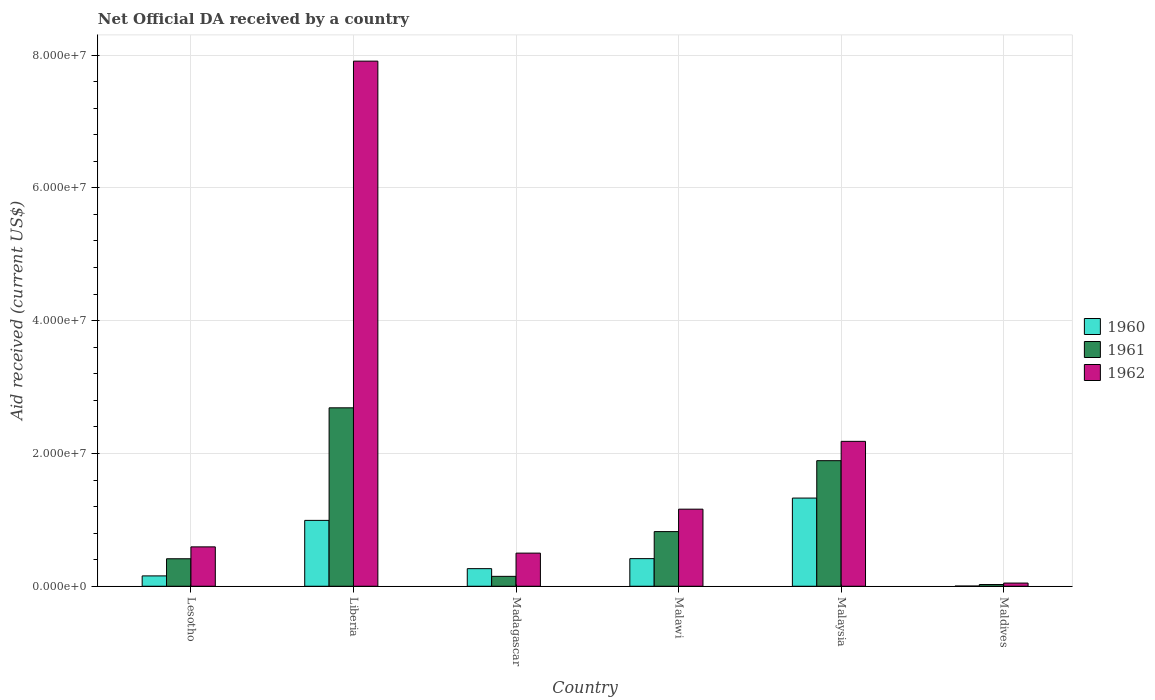Are the number of bars on each tick of the X-axis equal?
Make the answer very short. Yes. How many bars are there on the 1st tick from the left?
Provide a short and direct response. 3. What is the label of the 6th group of bars from the left?
Provide a short and direct response. Maldives. In how many cases, is the number of bars for a given country not equal to the number of legend labels?
Ensure brevity in your answer.  0. What is the net official development assistance aid received in 1960 in Liberia?
Offer a very short reply. 9.92e+06. Across all countries, what is the maximum net official development assistance aid received in 1960?
Keep it short and to the point. 1.33e+07. Across all countries, what is the minimum net official development assistance aid received in 1961?
Your answer should be very brief. 2.60e+05. In which country was the net official development assistance aid received in 1962 maximum?
Ensure brevity in your answer.  Liberia. In which country was the net official development assistance aid received in 1960 minimum?
Your response must be concise. Maldives. What is the total net official development assistance aid received in 1961 in the graph?
Your response must be concise. 5.99e+07. What is the difference between the net official development assistance aid received in 1960 in Liberia and that in Madagascar?
Ensure brevity in your answer.  7.27e+06. What is the difference between the net official development assistance aid received in 1961 in Malaysia and the net official development assistance aid received in 1962 in Madagascar?
Make the answer very short. 1.39e+07. What is the average net official development assistance aid received in 1960 per country?
Make the answer very short. 5.27e+06. What is the difference between the net official development assistance aid received of/in 1962 and net official development assistance aid received of/in 1961 in Liberia?
Give a very brief answer. 5.22e+07. What is the ratio of the net official development assistance aid received in 1961 in Madagascar to that in Malawi?
Your answer should be compact. 0.18. What is the difference between the highest and the second highest net official development assistance aid received in 1962?
Give a very brief answer. 5.73e+07. What is the difference between the highest and the lowest net official development assistance aid received in 1962?
Your response must be concise. 7.86e+07. Is the sum of the net official development assistance aid received in 1962 in Liberia and Madagascar greater than the maximum net official development assistance aid received in 1961 across all countries?
Make the answer very short. Yes. What does the 2nd bar from the right in Malawi represents?
Make the answer very short. 1961. Is it the case that in every country, the sum of the net official development assistance aid received in 1960 and net official development assistance aid received in 1962 is greater than the net official development assistance aid received in 1961?
Make the answer very short. Yes. How many bars are there?
Your answer should be very brief. 18. Does the graph contain any zero values?
Your answer should be very brief. No. Does the graph contain grids?
Give a very brief answer. Yes. How many legend labels are there?
Give a very brief answer. 3. What is the title of the graph?
Your answer should be compact. Net Official DA received by a country. Does "1977" appear as one of the legend labels in the graph?
Your answer should be compact. No. What is the label or title of the Y-axis?
Give a very brief answer. Aid received (current US$). What is the Aid received (current US$) in 1960 in Lesotho?
Your answer should be compact. 1.56e+06. What is the Aid received (current US$) of 1961 in Lesotho?
Make the answer very short. 4.14e+06. What is the Aid received (current US$) of 1962 in Lesotho?
Provide a short and direct response. 5.93e+06. What is the Aid received (current US$) of 1960 in Liberia?
Ensure brevity in your answer.  9.92e+06. What is the Aid received (current US$) of 1961 in Liberia?
Give a very brief answer. 2.69e+07. What is the Aid received (current US$) in 1962 in Liberia?
Make the answer very short. 7.91e+07. What is the Aid received (current US$) of 1960 in Madagascar?
Ensure brevity in your answer.  2.65e+06. What is the Aid received (current US$) in 1961 in Madagascar?
Ensure brevity in your answer.  1.49e+06. What is the Aid received (current US$) in 1962 in Madagascar?
Offer a terse response. 4.99e+06. What is the Aid received (current US$) of 1960 in Malawi?
Your response must be concise. 4.16e+06. What is the Aid received (current US$) of 1961 in Malawi?
Provide a succinct answer. 8.23e+06. What is the Aid received (current US$) of 1962 in Malawi?
Provide a succinct answer. 1.16e+07. What is the Aid received (current US$) of 1960 in Malaysia?
Your answer should be very brief. 1.33e+07. What is the Aid received (current US$) of 1961 in Malaysia?
Your answer should be very brief. 1.89e+07. What is the Aid received (current US$) of 1962 in Malaysia?
Your response must be concise. 2.18e+07. What is the Aid received (current US$) of 1960 in Maldives?
Make the answer very short. 3.00e+04. Across all countries, what is the maximum Aid received (current US$) in 1960?
Offer a terse response. 1.33e+07. Across all countries, what is the maximum Aid received (current US$) in 1961?
Your answer should be very brief. 2.69e+07. Across all countries, what is the maximum Aid received (current US$) in 1962?
Keep it short and to the point. 7.91e+07. Across all countries, what is the minimum Aid received (current US$) of 1960?
Provide a short and direct response. 3.00e+04. What is the total Aid received (current US$) in 1960 in the graph?
Give a very brief answer. 3.16e+07. What is the total Aid received (current US$) in 1961 in the graph?
Your response must be concise. 5.99e+07. What is the total Aid received (current US$) of 1962 in the graph?
Ensure brevity in your answer.  1.24e+08. What is the difference between the Aid received (current US$) of 1960 in Lesotho and that in Liberia?
Provide a short and direct response. -8.36e+06. What is the difference between the Aid received (current US$) in 1961 in Lesotho and that in Liberia?
Your response must be concise. -2.27e+07. What is the difference between the Aid received (current US$) in 1962 in Lesotho and that in Liberia?
Your answer should be very brief. -7.32e+07. What is the difference between the Aid received (current US$) of 1960 in Lesotho and that in Madagascar?
Offer a very short reply. -1.09e+06. What is the difference between the Aid received (current US$) in 1961 in Lesotho and that in Madagascar?
Offer a very short reply. 2.65e+06. What is the difference between the Aid received (current US$) in 1962 in Lesotho and that in Madagascar?
Keep it short and to the point. 9.40e+05. What is the difference between the Aid received (current US$) in 1960 in Lesotho and that in Malawi?
Your answer should be very brief. -2.60e+06. What is the difference between the Aid received (current US$) of 1961 in Lesotho and that in Malawi?
Your response must be concise. -4.09e+06. What is the difference between the Aid received (current US$) in 1962 in Lesotho and that in Malawi?
Give a very brief answer. -5.68e+06. What is the difference between the Aid received (current US$) in 1960 in Lesotho and that in Malaysia?
Your answer should be compact. -1.17e+07. What is the difference between the Aid received (current US$) in 1961 in Lesotho and that in Malaysia?
Your response must be concise. -1.48e+07. What is the difference between the Aid received (current US$) of 1962 in Lesotho and that in Malaysia?
Your response must be concise. -1.59e+07. What is the difference between the Aid received (current US$) of 1960 in Lesotho and that in Maldives?
Offer a very short reply. 1.53e+06. What is the difference between the Aid received (current US$) in 1961 in Lesotho and that in Maldives?
Make the answer very short. 3.88e+06. What is the difference between the Aid received (current US$) in 1962 in Lesotho and that in Maldives?
Your response must be concise. 5.45e+06. What is the difference between the Aid received (current US$) in 1960 in Liberia and that in Madagascar?
Provide a succinct answer. 7.27e+06. What is the difference between the Aid received (current US$) in 1961 in Liberia and that in Madagascar?
Make the answer very short. 2.54e+07. What is the difference between the Aid received (current US$) of 1962 in Liberia and that in Madagascar?
Provide a succinct answer. 7.41e+07. What is the difference between the Aid received (current US$) of 1960 in Liberia and that in Malawi?
Keep it short and to the point. 5.76e+06. What is the difference between the Aid received (current US$) of 1961 in Liberia and that in Malawi?
Your answer should be very brief. 1.86e+07. What is the difference between the Aid received (current US$) of 1962 in Liberia and that in Malawi?
Make the answer very short. 6.75e+07. What is the difference between the Aid received (current US$) of 1960 in Liberia and that in Malaysia?
Your response must be concise. -3.36e+06. What is the difference between the Aid received (current US$) of 1961 in Liberia and that in Malaysia?
Provide a short and direct response. 7.96e+06. What is the difference between the Aid received (current US$) of 1962 in Liberia and that in Malaysia?
Give a very brief answer. 5.73e+07. What is the difference between the Aid received (current US$) in 1960 in Liberia and that in Maldives?
Keep it short and to the point. 9.89e+06. What is the difference between the Aid received (current US$) in 1961 in Liberia and that in Maldives?
Your response must be concise. 2.66e+07. What is the difference between the Aid received (current US$) of 1962 in Liberia and that in Maldives?
Your response must be concise. 7.86e+07. What is the difference between the Aid received (current US$) of 1960 in Madagascar and that in Malawi?
Make the answer very short. -1.51e+06. What is the difference between the Aid received (current US$) of 1961 in Madagascar and that in Malawi?
Your answer should be very brief. -6.74e+06. What is the difference between the Aid received (current US$) in 1962 in Madagascar and that in Malawi?
Provide a succinct answer. -6.62e+06. What is the difference between the Aid received (current US$) of 1960 in Madagascar and that in Malaysia?
Your response must be concise. -1.06e+07. What is the difference between the Aid received (current US$) in 1961 in Madagascar and that in Malaysia?
Your answer should be very brief. -1.74e+07. What is the difference between the Aid received (current US$) in 1962 in Madagascar and that in Malaysia?
Your response must be concise. -1.68e+07. What is the difference between the Aid received (current US$) in 1960 in Madagascar and that in Maldives?
Provide a succinct answer. 2.62e+06. What is the difference between the Aid received (current US$) of 1961 in Madagascar and that in Maldives?
Provide a succinct answer. 1.23e+06. What is the difference between the Aid received (current US$) of 1962 in Madagascar and that in Maldives?
Offer a terse response. 4.51e+06. What is the difference between the Aid received (current US$) in 1960 in Malawi and that in Malaysia?
Keep it short and to the point. -9.12e+06. What is the difference between the Aid received (current US$) of 1961 in Malawi and that in Malaysia?
Offer a terse response. -1.07e+07. What is the difference between the Aid received (current US$) of 1962 in Malawi and that in Malaysia?
Your response must be concise. -1.02e+07. What is the difference between the Aid received (current US$) in 1960 in Malawi and that in Maldives?
Your response must be concise. 4.13e+06. What is the difference between the Aid received (current US$) of 1961 in Malawi and that in Maldives?
Offer a very short reply. 7.97e+06. What is the difference between the Aid received (current US$) of 1962 in Malawi and that in Maldives?
Keep it short and to the point. 1.11e+07. What is the difference between the Aid received (current US$) in 1960 in Malaysia and that in Maldives?
Offer a very short reply. 1.32e+07. What is the difference between the Aid received (current US$) in 1961 in Malaysia and that in Maldives?
Provide a succinct answer. 1.86e+07. What is the difference between the Aid received (current US$) of 1962 in Malaysia and that in Maldives?
Your response must be concise. 2.13e+07. What is the difference between the Aid received (current US$) in 1960 in Lesotho and the Aid received (current US$) in 1961 in Liberia?
Your response must be concise. -2.53e+07. What is the difference between the Aid received (current US$) of 1960 in Lesotho and the Aid received (current US$) of 1962 in Liberia?
Offer a terse response. -7.75e+07. What is the difference between the Aid received (current US$) of 1961 in Lesotho and the Aid received (current US$) of 1962 in Liberia?
Ensure brevity in your answer.  -7.49e+07. What is the difference between the Aid received (current US$) of 1960 in Lesotho and the Aid received (current US$) of 1961 in Madagascar?
Your answer should be very brief. 7.00e+04. What is the difference between the Aid received (current US$) in 1960 in Lesotho and the Aid received (current US$) in 1962 in Madagascar?
Offer a very short reply. -3.43e+06. What is the difference between the Aid received (current US$) in 1961 in Lesotho and the Aid received (current US$) in 1962 in Madagascar?
Give a very brief answer. -8.50e+05. What is the difference between the Aid received (current US$) in 1960 in Lesotho and the Aid received (current US$) in 1961 in Malawi?
Provide a succinct answer. -6.67e+06. What is the difference between the Aid received (current US$) of 1960 in Lesotho and the Aid received (current US$) of 1962 in Malawi?
Your answer should be compact. -1.00e+07. What is the difference between the Aid received (current US$) of 1961 in Lesotho and the Aid received (current US$) of 1962 in Malawi?
Offer a terse response. -7.47e+06. What is the difference between the Aid received (current US$) in 1960 in Lesotho and the Aid received (current US$) in 1961 in Malaysia?
Provide a short and direct response. -1.74e+07. What is the difference between the Aid received (current US$) in 1960 in Lesotho and the Aid received (current US$) in 1962 in Malaysia?
Provide a succinct answer. -2.03e+07. What is the difference between the Aid received (current US$) of 1961 in Lesotho and the Aid received (current US$) of 1962 in Malaysia?
Provide a succinct answer. -1.77e+07. What is the difference between the Aid received (current US$) in 1960 in Lesotho and the Aid received (current US$) in 1961 in Maldives?
Offer a very short reply. 1.30e+06. What is the difference between the Aid received (current US$) in 1960 in Lesotho and the Aid received (current US$) in 1962 in Maldives?
Keep it short and to the point. 1.08e+06. What is the difference between the Aid received (current US$) in 1961 in Lesotho and the Aid received (current US$) in 1962 in Maldives?
Give a very brief answer. 3.66e+06. What is the difference between the Aid received (current US$) in 1960 in Liberia and the Aid received (current US$) in 1961 in Madagascar?
Your response must be concise. 8.43e+06. What is the difference between the Aid received (current US$) of 1960 in Liberia and the Aid received (current US$) of 1962 in Madagascar?
Offer a very short reply. 4.93e+06. What is the difference between the Aid received (current US$) in 1961 in Liberia and the Aid received (current US$) in 1962 in Madagascar?
Offer a very short reply. 2.19e+07. What is the difference between the Aid received (current US$) of 1960 in Liberia and the Aid received (current US$) of 1961 in Malawi?
Offer a terse response. 1.69e+06. What is the difference between the Aid received (current US$) of 1960 in Liberia and the Aid received (current US$) of 1962 in Malawi?
Make the answer very short. -1.69e+06. What is the difference between the Aid received (current US$) in 1961 in Liberia and the Aid received (current US$) in 1962 in Malawi?
Keep it short and to the point. 1.53e+07. What is the difference between the Aid received (current US$) in 1960 in Liberia and the Aid received (current US$) in 1961 in Malaysia?
Make the answer very short. -8.99e+06. What is the difference between the Aid received (current US$) of 1960 in Liberia and the Aid received (current US$) of 1962 in Malaysia?
Offer a very short reply. -1.19e+07. What is the difference between the Aid received (current US$) of 1961 in Liberia and the Aid received (current US$) of 1962 in Malaysia?
Your answer should be very brief. 5.05e+06. What is the difference between the Aid received (current US$) of 1960 in Liberia and the Aid received (current US$) of 1961 in Maldives?
Give a very brief answer. 9.66e+06. What is the difference between the Aid received (current US$) in 1960 in Liberia and the Aid received (current US$) in 1962 in Maldives?
Ensure brevity in your answer.  9.44e+06. What is the difference between the Aid received (current US$) of 1961 in Liberia and the Aid received (current US$) of 1962 in Maldives?
Keep it short and to the point. 2.64e+07. What is the difference between the Aid received (current US$) in 1960 in Madagascar and the Aid received (current US$) in 1961 in Malawi?
Provide a short and direct response. -5.58e+06. What is the difference between the Aid received (current US$) of 1960 in Madagascar and the Aid received (current US$) of 1962 in Malawi?
Your answer should be very brief. -8.96e+06. What is the difference between the Aid received (current US$) of 1961 in Madagascar and the Aid received (current US$) of 1962 in Malawi?
Offer a terse response. -1.01e+07. What is the difference between the Aid received (current US$) of 1960 in Madagascar and the Aid received (current US$) of 1961 in Malaysia?
Keep it short and to the point. -1.63e+07. What is the difference between the Aid received (current US$) of 1960 in Madagascar and the Aid received (current US$) of 1962 in Malaysia?
Your answer should be very brief. -1.92e+07. What is the difference between the Aid received (current US$) of 1961 in Madagascar and the Aid received (current US$) of 1962 in Malaysia?
Your response must be concise. -2.03e+07. What is the difference between the Aid received (current US$) in 1960 in Madagascar and the Aid received (current US$) in 1961 in Maldives?
Keep it short and to the point. 2.39e+06. What is the difference between the Aid received (current US$) in 1960 in Madagascar and the Aid received (current US$) in 1962 in Maldives?
Provide a succinct answer. 2.17e+06. What is the difference between the Aid received (current US$) in 1961 in Madagascar and the Aid received (current US$) in 1962 in Maldives?
Offer a very short reply. 1.01e+06. What is the difference between the Aid received (current US$) of 1960 in Malawi and the Aid received (current US$) of 1961 in Malaysia?
Your response must be concise. -1.48e+07. What is the difference between the Aid received (current US$) in 1960 in Malawi and the Aid received (current US$) in 1962 in Malaysia?
Provide a short and direct response. -1.77e+07. What is the difference between the Aid received (current US$) in 1961 in Malawi and the Aid received (current US$) in 1962 in Malaysia?
Your answer should be very brief. -1.36e+07. What is the difference between the Aid received (current US$) in 1960 in Malawi and the Aid received (current US$) in 1961 in Maldives?
Provide a short and direct response. 3.90e+06. What is the difference between the Aid received (current US$) of 1960 in Malawi and the Aid received (current US$) of 1962 in Maldives?
Your answer should be compact. 3.68e+06. What is the difference between the Aid received (current US$) in 1961 in Malawi and the Aid received (current US$) in 1962 in Maldives?
Your answer should be very brief. 7.75e+06. What is the difference between the Aid received (current US$) in 1960 in Malaysia and the Aid received (current US$) in 1961 in Maldives?
Ensure brevity in your answer.  1.30e+07. What is the difference between the Aid received (current US$) of 1960 in Malaysia and the Aid received (current US$) of 1962 in Maldives?
Your answer should be very brief. 1.28e+07. What is the difference between the Aid received (current US$) in 1961 in Malaysia and the Aid received (current US$) in 1962 in Maldives?
Make the answer very short. 1.84e+07. What is the average Aid received (current US$) of 1960 per country?
Offer a terse response. 5.27e+06. What is the average Aid received (current US$) in 1961 per country?
Provide a succinct answer. 9.98e+06. What is the average Aid received (current US$) in 1962 per country?
Make the answer very short. 2.07e+07. What is the difference between the Aid received (current US$) of 1960 and Aid received (current US$) of 1961 in Lesotho?
Your answer should be very brief. -2.58e+06. What is the difference between the Aid received (current US$) in 1960 and Aid received (current US$) in 1962 in Lesotho?
Provide a short and direct response. -4.37e+06. What is the difference between the Aid received (current US$) of 1961 and Aid received (current US$) of 1962 in Lesotho?
Offer a very short reply. -1.79e+06. What is the difference between the Aid received (current US$) in 1960 and Aid received (current US$) in 1961 in Liberia?
Provide a succinct answer. -1.70e+07. What is the difference between the Aid received (current US$) of 1960 and Aid received (current US$) of 1962 in Liberia?
Make the answer very short. -6.92e+07. What is the difference between the Aid received (current US$) in 1961 and Aid received (current US$) in 1962 in Liberia?
Offer a very short reply. -5.22e+07. What is the difference between the Aid received (current US$) in 1960 and Aid received (current US$) in 1961 in Madagascar?
Ensure brevity in your answer.  1.16e+06. What is the difference between the Aid received (current US$) in 1960 and Aid received (current US$) in 1962 in Madagascar?
Your response must be concise. -2.34e+06. What is the difference between the Aid received (current US$) in 1961 and Aid received (current US$) in 1962 in Madagascar?
Offer a terse response. -3.50e+06. What is the difference between the Aid received (current US$) in 1960 and Aid received (current US$) in 1961 in Malawi?
Provide a short and direct response. -4.07e+06. What is the difference between the Aid received (current US$) of 1960 and Aid received (current US$) of 1962 in Malawi?
Your answer should be very brief. -7.45e+06. What is the difference between the Aid received (current US$) of 1961 and Aid received (current US$) of 1962 in Malawi?
Offer a terse response. -3.38e+06. What is the difference between the Aid received (current US$) in 1960 and Aid received (current US$) in 1961 in Malaysia?
Give a very brief answer. -5.63e+06. What is the difference between the Aid received (current US$) of 1960 and Aid received (current US$) of 1962 in Malaysia?
Offer a terse response. -8.54e+06. What is the difference between the Aid received (current US$) of 1961 and Aid received (current US$) of 1962 in Malaysia?
Give a very brief answer. -2.91e+06. What is the difference between the Aid received (current US$) in 1960 and Aid received (current US$) in 1962 in Maldives?
Offer a very short reply. -4.50e+05. What is the ratio of the Aid received (current US$) of 1960 in Lesotho to that in Liberia?
Your answer should be very brief. 0.16. What is the ratio of the Aid received (current US$) of 1961 in Lesotho to that in Liberia?
Keep it short and to the point. 0.15. What is the ratio of the Aid received (current US$) of 1962 in Lesotho to that in Liberia?
Make the answer very short. 0.07. What is the ratio of the Aid received (current US$) of 1960 in Lesotho to that in Madagascar?
Ensure brevity in your answer.  0.59. What is the ratio of the Aid received (current US$) of 1961 in Lesotho to that in Madagascar?
Your response must be concise. 2.78. What is the ratio of the Aid received (current US$) of 1962 in Lesotho to that in Madagascar?
Give a very brief answer. 1.19. What is the ratio of the Aid received (current US$) of 1960 in Lesotho to that in Malawi?
Ensure brevity in your answer.  0.38. What is the ratio of the Aid received (current US$) of 1961 in Lesotho to that in Malawi?
Your answer should be very brief. 0.5. What is the ratio of the Aid received (current US$) of 1962 in Lesotho to that in Malawi?
Your response must be concise. 0.51. What is the ratio of the Aid received (current US$) in 1960 in Lesotho to that in Malaysia?
Make the answer very short. 0.12. What is the ratio of the Aid received (current US$) of 1961 in Lesotho to that in Malaysia?
Your answer should be compact. 0.22. What is the ratio of the Aid received (current US$) in 1962 in Lesotho to that in Malaysia?
Your answer should be very brief. 0.27. What is the ratio of the Aid received (current US$) in 1961 in Lesotho to that in Maldives?
Provide a short and direct response. 15.92. What is the ratio of the Aid received (current US$) in 1962 in Lesotho to that in Maldives?
Your answer should be compact. 12.35. What is the ratio of the Aid received (current US$) of 1960 in Liberia to that in Madagascar?
Provide a short and direct response. 3.74. What is the ratio of the Aid received (current US$) of 1961 in Liberia to that in Madagascar?
Your answer should be compact. 18.03. What is the ratio of the Aid received (current US$) of 1962 in Liberia to that in Madagascar?
Offer a very short reply. 15.85. What is the ratio of the Aid received (current US$) in 1960 in Liberia to that in Malawi?
Give a very brief answer. 2.38. What is the ratio of the Aid received (current US$) of 1961 in Liberia to that in Malawi?
Offer a very short reply. 3.26. What is the ratio of the Aid received (current US$) of 1962 in Liberia to that in Malawi?
Make the answer very short. 6.81. What is the ratio of the Aid received (current US$) of 1960 in Liberia to that in Malaysia?
Give a very brief answer. 0.75. What is the ratio of the Aid received (current US$) of 1961 in Liberia to that in Malaysia?
Offer a very short reply. 1.42. What is the ratio of the Aid received (current US$) in 1962 in Liberia to that in Malaysia?
Your answer should be compact. 3.62. What is the ratio of the Aid received (current US$) in 1960 in Liberia to that in Maldives?
Your response must be concise. 330.67. What is the ratio of the Aid received (current US$) in 1961 in Liberia to that in Maldives?
Your answer should be very brief. 103.35. What is the ratio of the Aid received (current US$) in 1962 in Liberia to that in Maldives?
Your response must be concise. 164.75. What is the ratio of the Aid received (current US$) of 1960 in Madagascar to that in Malawi?
Your answer should be very brief. 0.64. What is the ratio of the Aid received (current US$) in 1961 in Madagascar to that in Malawi?
Give a very brief answer. 0.18. What is the ratio of the Aid received (current US$) in 1962 in Madagascar to that in Malawi?
Your answer should be compact. 0.43. What is the ratio of the Aid received (current US$) in 1960 in Madagascar to that in Malaysia?
Offer a very short reply. 0.2. What is the ratio of the Aid received (current US$) of 1961 in Madagascar to that in Malaysia?
Offer a terse response. 0.08. What is the ratio of the Aid received (current US$) of 1962 in Madagascar to that in Malaysia?
Your answer should be compact. 0.23. What is the ratio of the Aid received (current US$) in 1960 in Madagascar to that in Maldives?
Your answer should be compact. 88.33. What is the ratio of the Aid received (current US$) in 1961 in Madagascar to that in Maldives?
Make the answer very short. 5.73. What is the ratio of the Aid received (current US$) of 1962 in Madagascar to that in Maldives?
Offer a terse response. 10.4. What is the ratio of the Aid received (current US$) in 1960 in Malawi to that in Malaysia?
Your response must be concise. 0.31. What is the ratio of the Aid received (current US$) in 1961 in Malawi to that in Malaysia?
Offer a very short reply. 0.44. What is the ratio of the Aid received (current US$) of 1962 in Malawi to that in Malaysia?
Make the answer very short. 0.53. What is the ratio of the Aid received (current US$) of 1960 in Malawi to that in Maldives?
Provide a succinct answer. 138.67. What is the ratio of the Aid received (current US$) in 1961 in Malawi to that in Maldives?
Ensure brevity in your answer.  31.65. What is the ratio of the Aid received (current US$) in 1962 in Malawi to that in Maldives?
Offer a terse response. 24.19. What is the ratio of the Aid received (current US$) in 1960 in Malaysia to that in Maldives?
Your answer should be compact. 442.67. What is the ratio of the Aid received (current US$) of 1961 in Malaysia to that in Maldives?
Your answer should be very brief. 72.73. What is the ratio of the Aid received (current US$) of 1962 in Malaysia to that in Maldives?
Offer a terse response. 45.46. What is the difference between the highest and the second highest Aid received (current US$) of 1960?
Provide a succinct answer. 3.36e+06. What is the difference between the highest and the second highest Aid received (current US$) in 1961?
Make the answer very short. 7.96e+06. What is the difference between the highest and the second highest Aid received (current US$) in 1962?
Give a very brief answer. 5.73e+07. What is the difference between the highest and the lowest Aid received (current US$) in 1960?
Provide a succinct answer. 1.32e+07. What is the difference between the highest and the lowest Aid received (current US$) in 1961?
Your answer should be very brief. 2.66e+07. What is the difference between the highest and the lowest Aid received (current US$) in 1962?
Give a very brief answer. 7.86e+07. 